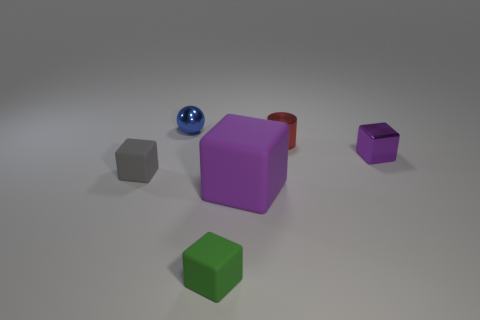Add 3 small blue balls. How many objects exist? 9 Subtract all cylinders. How many objects are left? 5 Subtract all large purple metal cylinders. Subtract all tiny matte cubes. How many objects are left? 4 Add 4 rubber objects. How many rubber objects are left? 7 Add 5 blue objects. How many blue objects exist? 6 Subtract 0 gray balls. How many objects are left? 6 